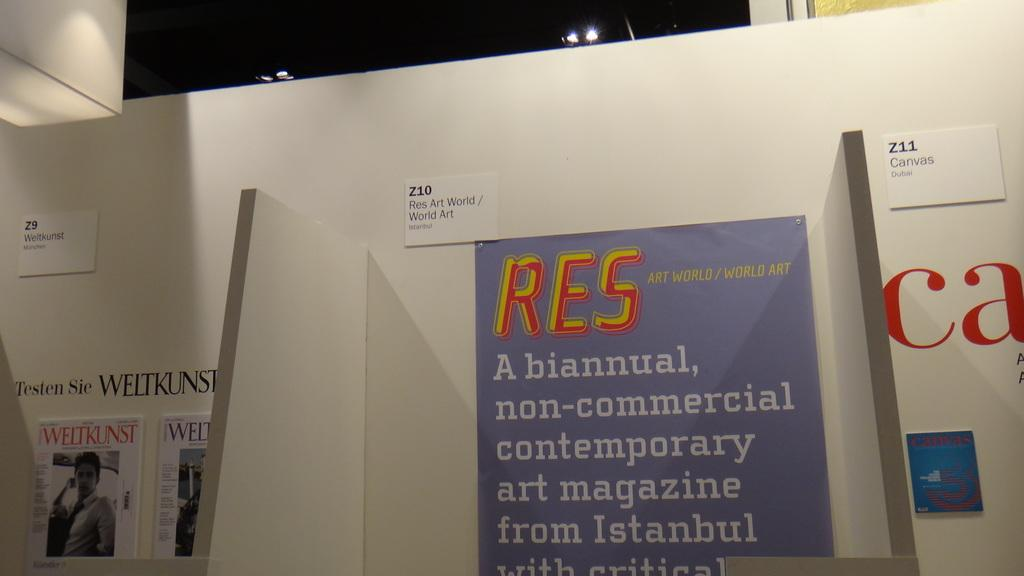<image>
Give a short and clear explanation of the subsequent image. A large poster stuck to a wall that reads RES - Art World / World Art. 